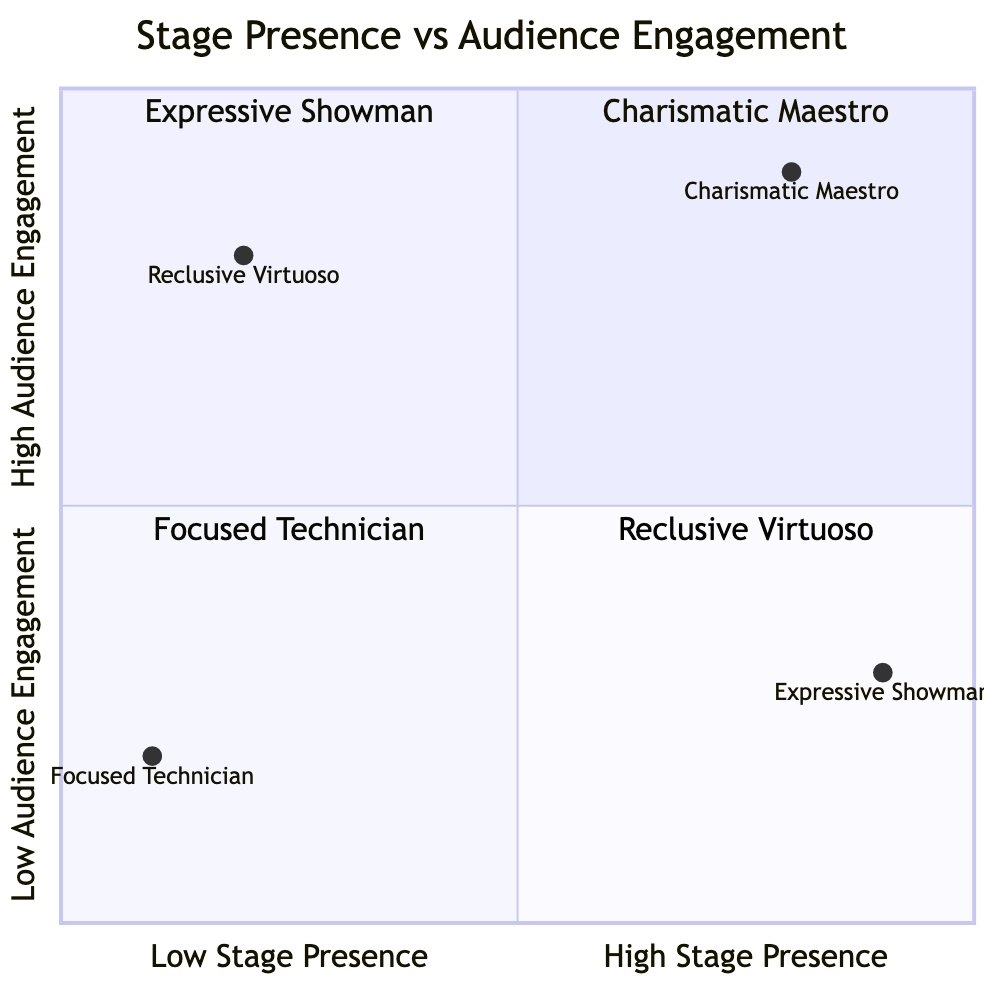What's the stage presence of the Charismatic Maestro? According to the data provided, the stage presence of the Charismatic Maestro is categorized as "High."
Answer: High What's the audience engagement level of the Reclusive Virtuoso? The data states that the Reclusive Virtuoso has "High" audience engagement.
Answer: High Which element has low stage presence and low audience engagement? By examining the diagram, the element located in the quadrant with low stage presence and low audience engagement is the Focused Technician.
Answer: Focused Technician What is the stage presence of the Expressive Showman? The diagram indicates that the stage presence of the Expressive Showman is "High."
Answer: High How many elements are in the high audience engagement quadrant? The diagram features two elements that fall within the high audience engagement quadrant, namely the Charismatic Maestro and the Reclusive Virtuoso.
Answer: 2 Which element is located in the lower-left quadrant? The Focused Technician is the element positioned in the lower-left quadrant, which signifies low stage presence and low audience engagement.
Answer: Focused Technician Which conductor is characterized as both engaging and magnetic? The Charismatic Maestro is described as a highly engaging conductor with a magnetic stage presence.
Answer: Charismatic Maestro What can be inferred about the stage presence of both the Expressive Showman and Charismatic Maestro? Both the Expressive Showman and Charismatic Maestro have high stage presence, indicating they both excel in captivating the audience visually.
Answer: High Which element focuses more on the music than the audience? The Reclusive Virtuoso is noted for having a reserved demeanor and focusing more on the music than engaging with the audience.
Answer: Reclusive Virtuoso 